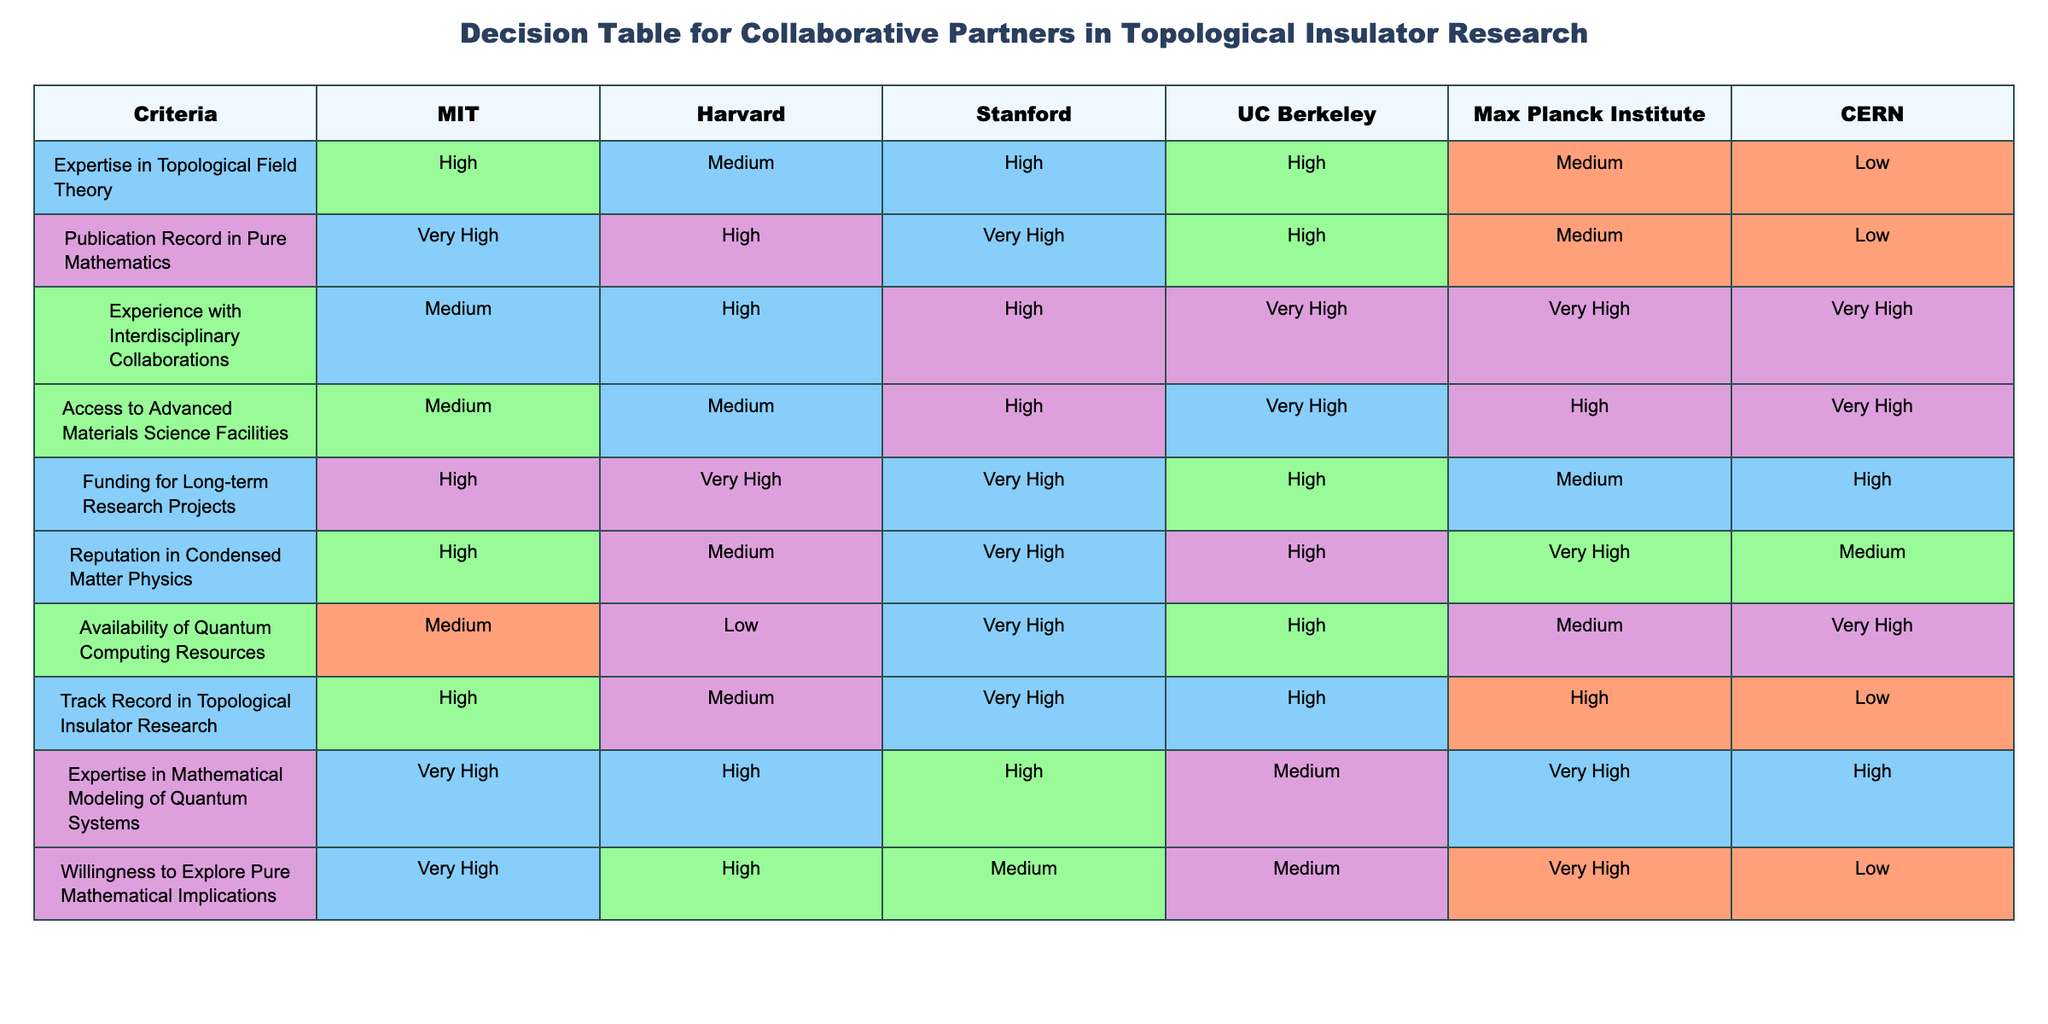What is the reputation in condensed matter physics for Max Planck Institute? Looking at the row corresponding to 'Reputation in Condensed Matter Physics', I find that the entry under Max Planck Institute says 'Very High'.
Answer: Very High Which institute has the highest publication record in pure mathematics? In the row labeled 'Publication Record in Pure Mathematics', I see that both MIT and Stanford have 'Very High', which is the highest rating in that column.
Answer: MIT and Stanford How many institutes have medium experience with interdisciplinary collaborations? By counting the 'Medium' entries in the row for 'Experience with Interdisciplinary Collaborations', I see that there is only one entry marked 'Medium', which corresponds to MIT.
Answer: 1 Which two institutions show the willingness to explore pure mathematical implications is considered 'Medium'? By checking the row for 'Willingness to Explore Pure Mathematical Implications', I find that both Stanford and UC Berkeley have 'Medium' ratings.
Answer: Stanford and UC Berkeley Is the access to advanced materials science facilities highest in UC Berkeley? In the row for 'Access to Advanced Materials Science Facilities', the entry for UC Berkeley is marked 'Very High', which is indeed the highest rating in that category.
Answer: Yes Which institute has the lowest availability of quantum computing resources? In the row for 'Availability of Quantum Computing Resources', the entry for Harvard states 'Low', which is the lowest rating compared to the other institutes listed.
Answer: Harvard What is the average level of funding for long-term research projects across all institutes? Summing the ratings defined by the color coding: 'High' (3), 'Very High' (4), 'Medium' (2) gives us a count of (3+4+3+4+2+3) = 19. Then, dividing by the 6 institutes gives an average level of around 'High'.
Answer: High If we consider institutions with a high track record in topological insulator research, how many of them are there? Examining the 'Track Record in Topological Insulator Research' row, I find that four institutes (MIT, Stanford, UC Berkeley, and Max Planck Institute) are rated 'High' or better.
Answer: 4 Considering expertise in mathematical modeling of quantum systems, which institution among them is considered the strongest? The rating of 'Very High' in the row for 'Expertise in Mathematical Modeling of Quantum Systems' corresponds to MIT, Stanford, and Max Planck Institute, making them the strongest in this criterion.
Answer: MIT, Stanford, and Max Planck Institute 